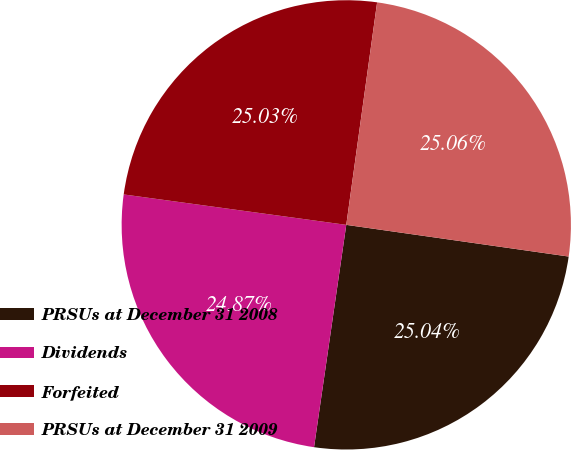Convert chart to OTSL. <chart><loc_0><loc_0><loc_500><loc_500><pie_chart><fcel>PRSUs at December 31 2008<fcel>Dividends<fcel>Forfeited<fcel>PRSUs at December 31 2009<nl><fcel>25.04%<fcel>24.87%<fcel>25.03%<fcel>25.06%<nl></chart> 